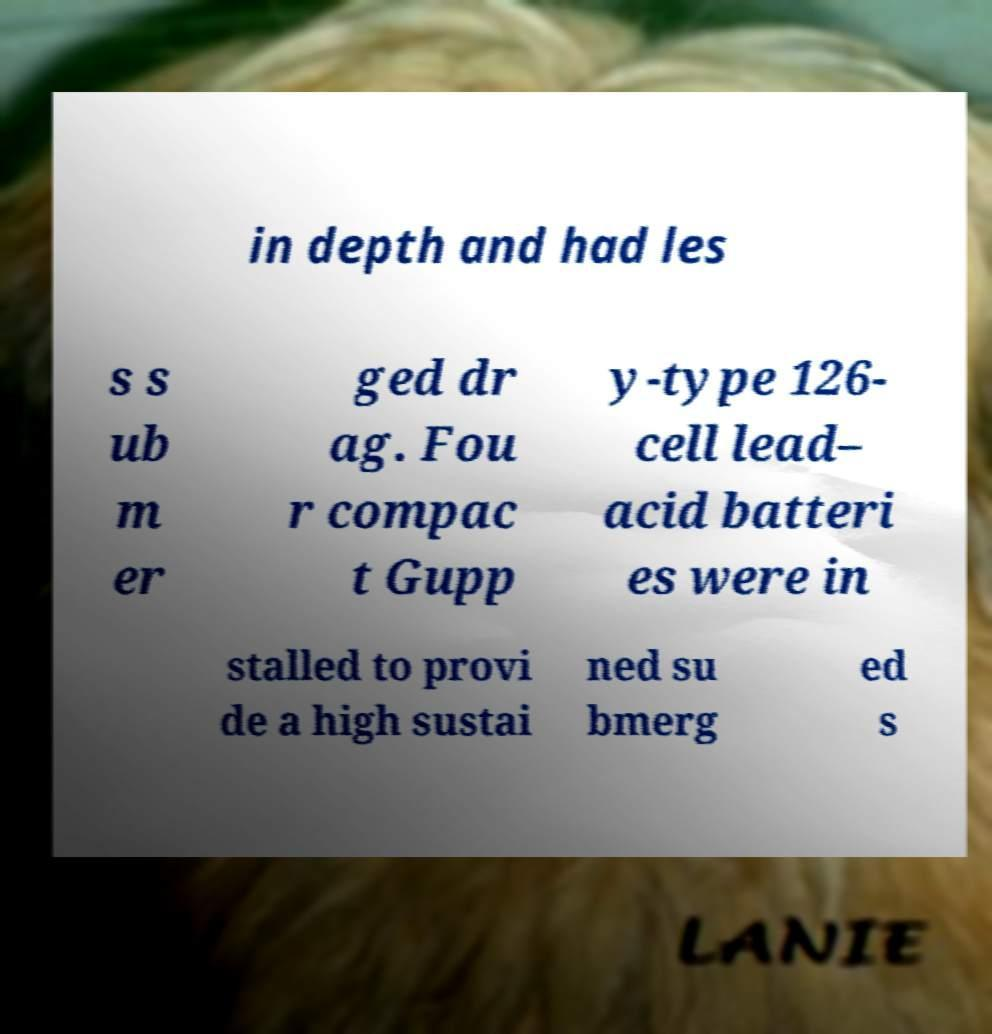What messages or text are displayed in this image? I need them in a readable, typed format. in depth and had les s s ub m er ged dr ag. Fou r compac t Gupp y-type 126- cell lead– acid batteri es were in stalled to provi de a high sustai ned su bmerg ed s 